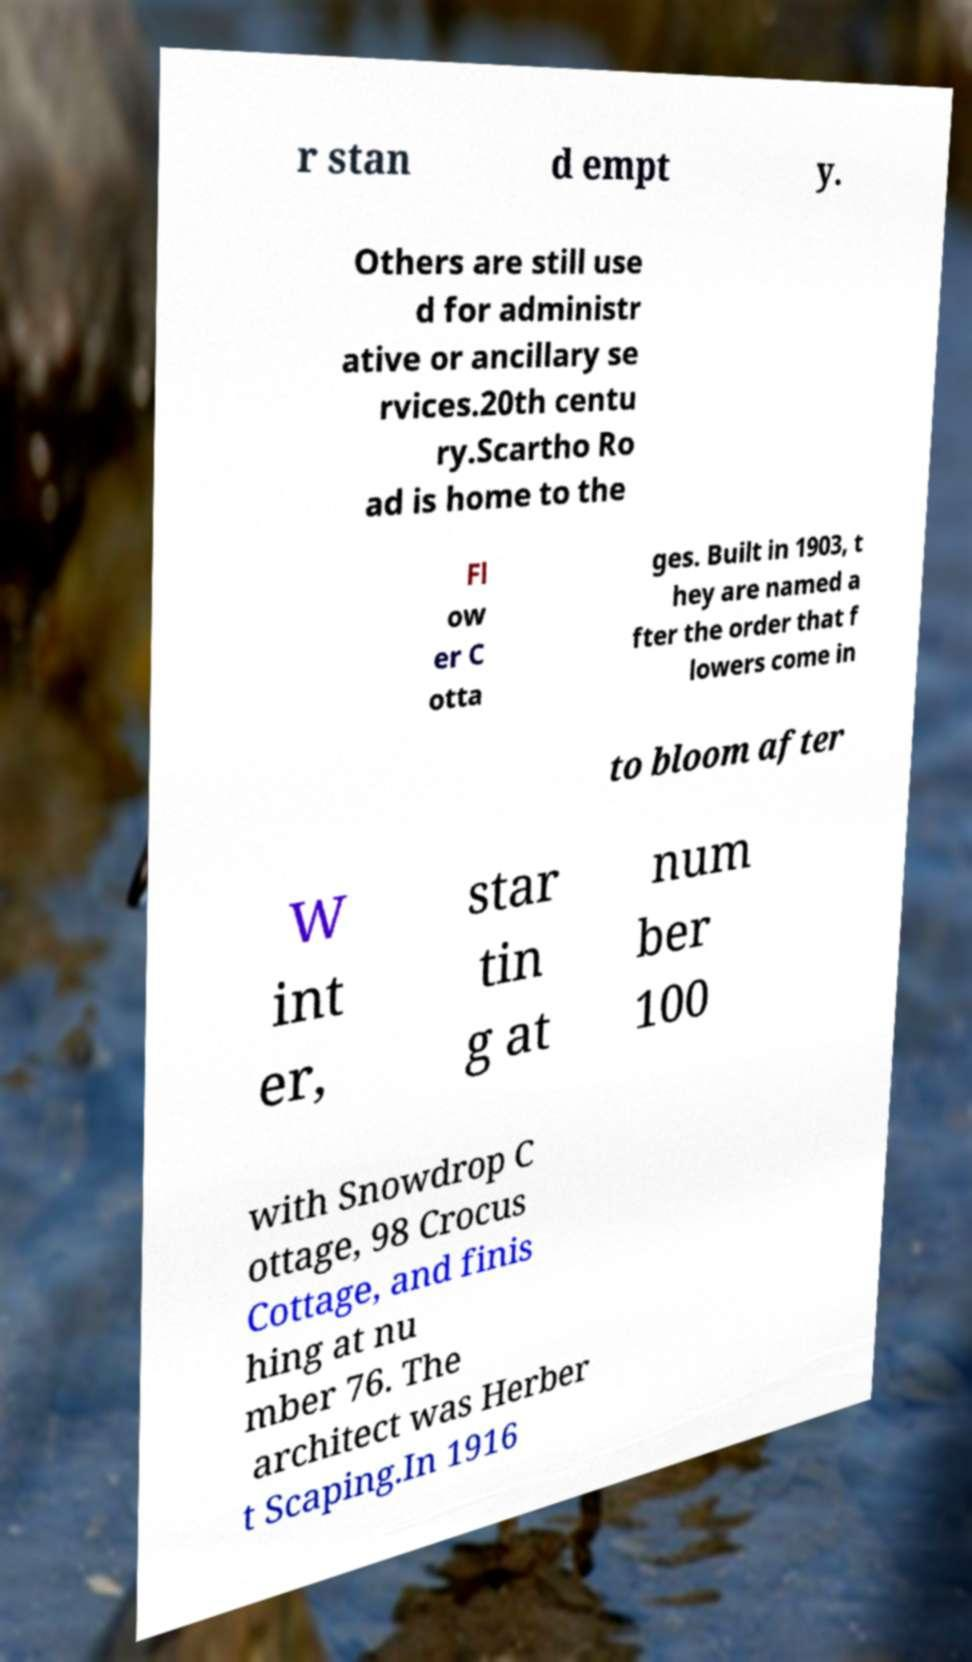Please identify and transcribe the text found in this image. r stan d empt y. Others are still use d for administr ative or ancillary se rvices.20th centu ry.Scartho Ro ad is home to the Fl ow er C otta ges. Built in 1903, t hey are named a fter the order that f lowers come in to bloom after W int er, star tin g at num ber 100 with Snowdrop C ottage, 98 Crocus Cottage, and finis hing at nu mber 76. The architect was Herber t Scaping.In 1916 